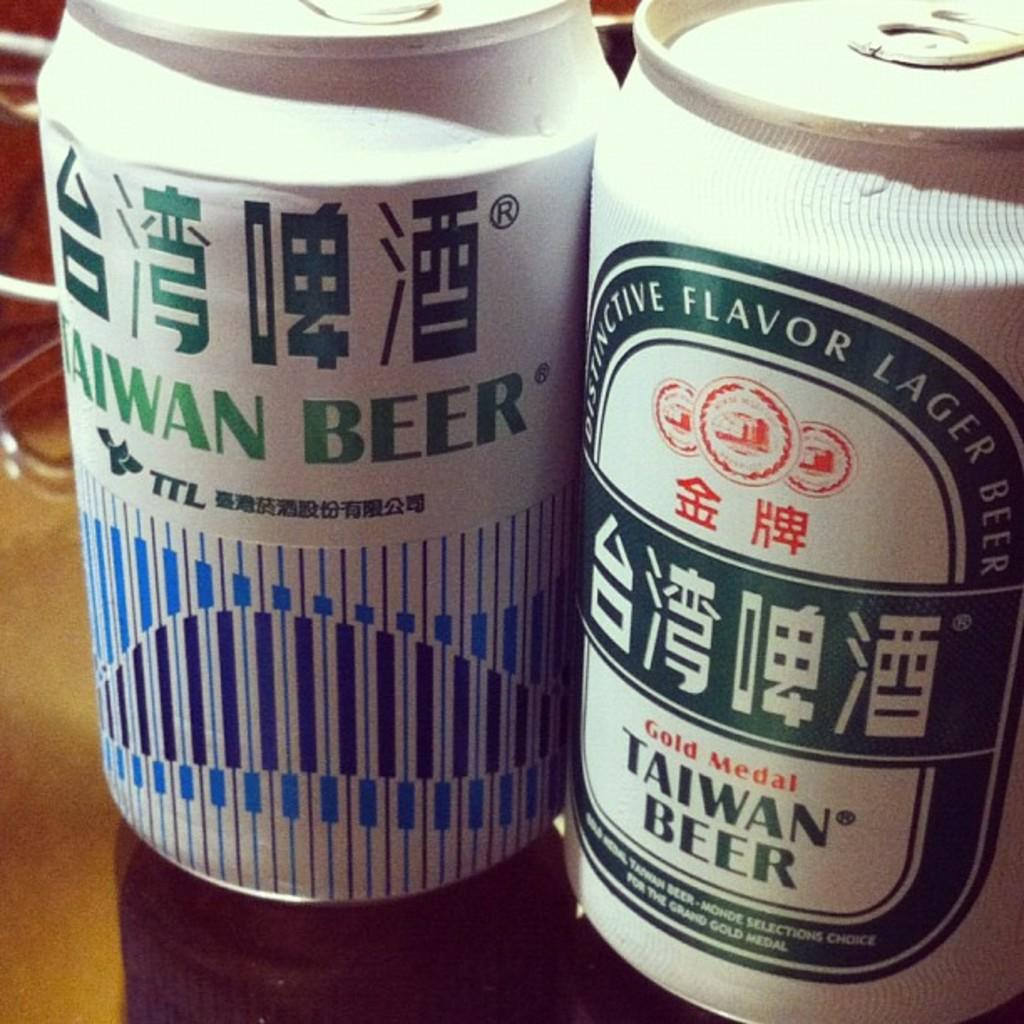<image>
Summarize the visual content of the image. Two cans of Taiwan Beer with one that states it is a gold medal. 